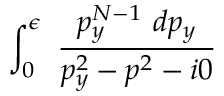<formula> <loc_0><loc_0><loc_500><loc_500>\int _ { 0 } ^ { \epsilon } \frac { p _ { y } ^ { N - 1 } d p _ { y } } { p _ { y } ^ { 2 } - p ^ { 2 } - i 0 }</formula> 